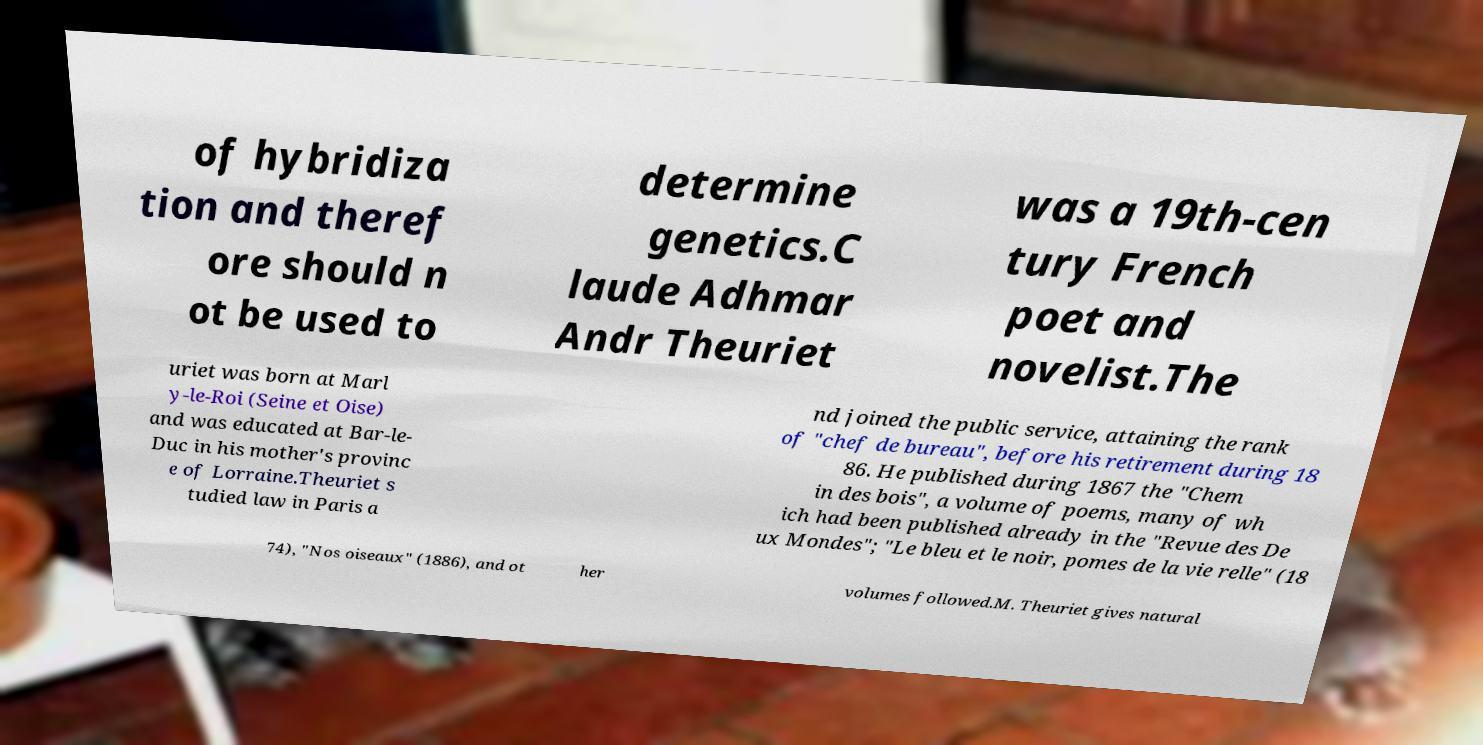There's text embedded in this image that I need extracted. Can you transcribe it verbatim? of hybridiza tion and theref ore should n ot be used to determine genetics.C laude Adhmar Andr Theuriet was a 19th-cen tury French poet and novelist.The uriet was born at Marl y-le-Roi (Seine et Oise) and was educated at Bar-le- Duc in his mother's provinc e of Lorraine.Theuriet s tudied law in Paris a nd joined the public service, attaining the rank of "chef de bureau", before his retirement during 18 86. He published during 1867 the "Chem in des bois", a volume of poems, many of wh ich had been published already in the "Revue des De ux Mondes"; "Le bleu et le noir, pomes de la vie relle" (18 74), "Nos oiseaux" (1886), and ot her volumes followed.M. Theuriet gives natural 